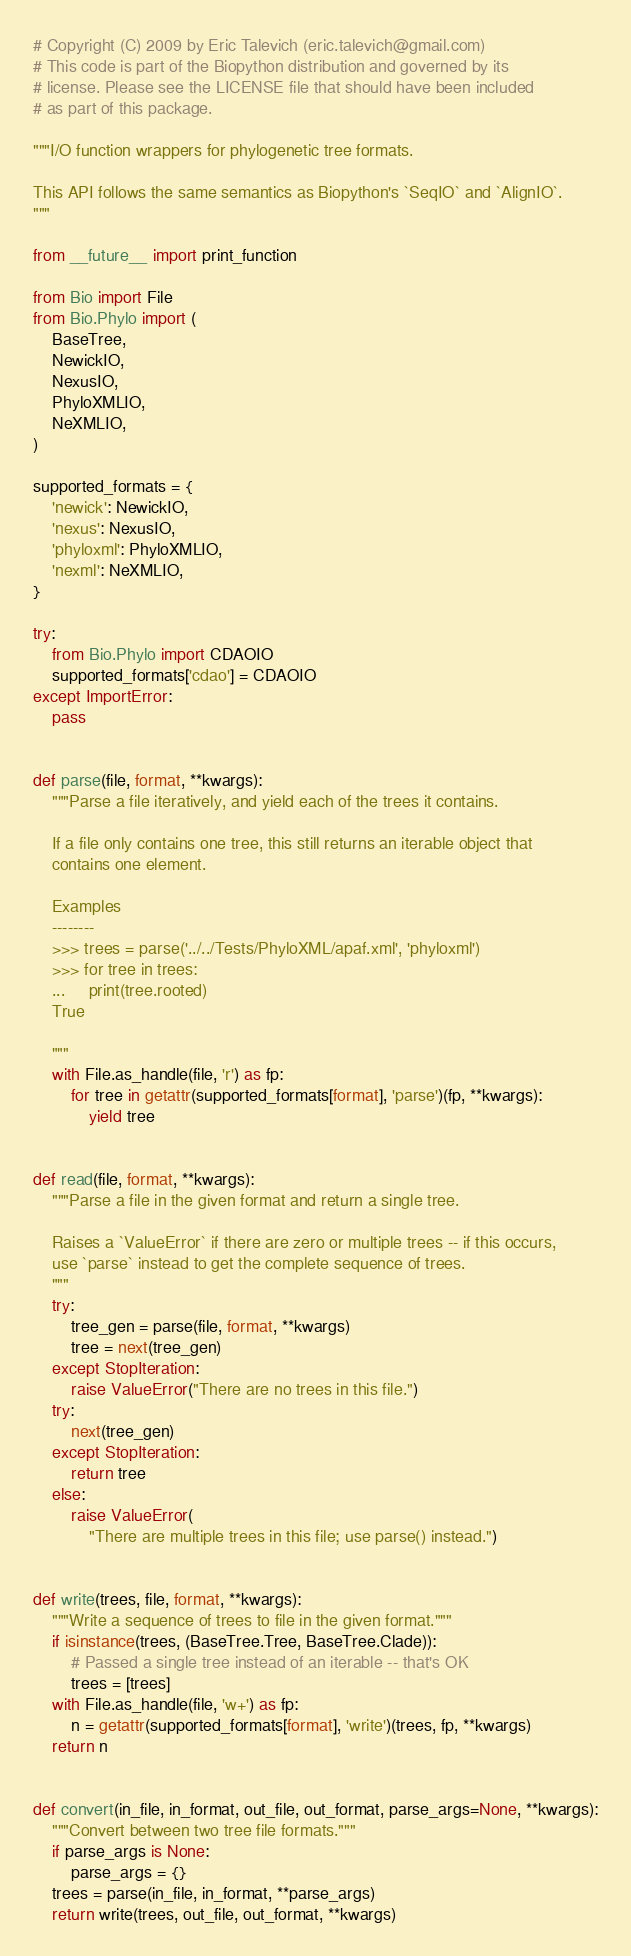<code> <loc_0><loc_0><loc_500><loc_500><_Python_># Copyright (C) 2009 by Eric Talevich (eric.talevich@gmail.com)
# This code is part of the Biopython distribution and governed by its
# license. Please see the LICENSE file that should have been included
# as part of this package.

"""I/O function wrappers for phylogenetic tree formats.

This API follows the same semantics as Biopython's `SeqIO` and `AlignIO`.
"""

from __future__ import print_function

from Bio import File
from Bio.Phylo import (
    BaseTree,
    NewickIO,
    NexusIO,
    PhyloXMLIO,
    NeXMLIO,
)

supported_formats = {
    'newick': NewickIO,
    'nexus': NexusIO,
    'phyloxml': PhyloXMLIO,
    'nexml': NeXMLIO,
}

try:
    from Bio.Phylo import CDAOIO
    supported_formats['cdao'] = CDAOIO
except ImportError:
    pass


def parse(file, format, **kwargs):
    """Parse a file iteratively, and yield each of the trees it contains.

    If a file only contains one tree, this still returns an iterable object that
    contains one element.

    Examples
    --------
    >>> trees = parse('../../Tests/PhyloXML/apaf.xml', 'phyloxml')
    >>> for tree in trees:
    ...     print(tree.rooted)
    True

    """
    with File.as_handle(file, 'r') as fp:
        for tree in getattr(supported_formats[format], 'parse')(fp, **kwargs):
            yield tree


def read(file, format, **kwargs):
    """Parse a file in the given format and return a single tree.

    Raises a `ValueError` if there are zero or multiple trees -- if this occurs,
    use `parse` instead to get the complete sequence of trees.
    """
    try:
        tree_gen = parse(file, format, **kwargs)
        tree = next(tree_gen)
    except StopIteration:
        raise ValueError("There are no trees in this file.")
    try:
        next(tree_gen)
    except StopIteration:
        return tree
    else:
        raise ValueError(
            "There are multiple trees in this file; use parse() instead.")


def write(trees, file, format, **kwargs):
    """Write a sequence of trees to file in the given format."""
    if isinstance(trees, (BaseTree.Tree, BaseTree.Clade)):
        # Passed a single tree instead of an iterable -- that's OK
        trees = [trees]
    with File.as_handle(file, 'w+') as fp:
        n = getattr(supported_formats[format], 'write')(trees, fp, **kwargs)
    return n


def convert(in_file, in_format, out_file, out_format, parse_args=None, **kwargs):
    """Convert between two tree file formats."""
    if parse_args is None:
        parse_args = {}
    trees = parse(in_file, in_format, **parse_args)
    return write(trees, out_file, out_format, **kwargs)
</code> 